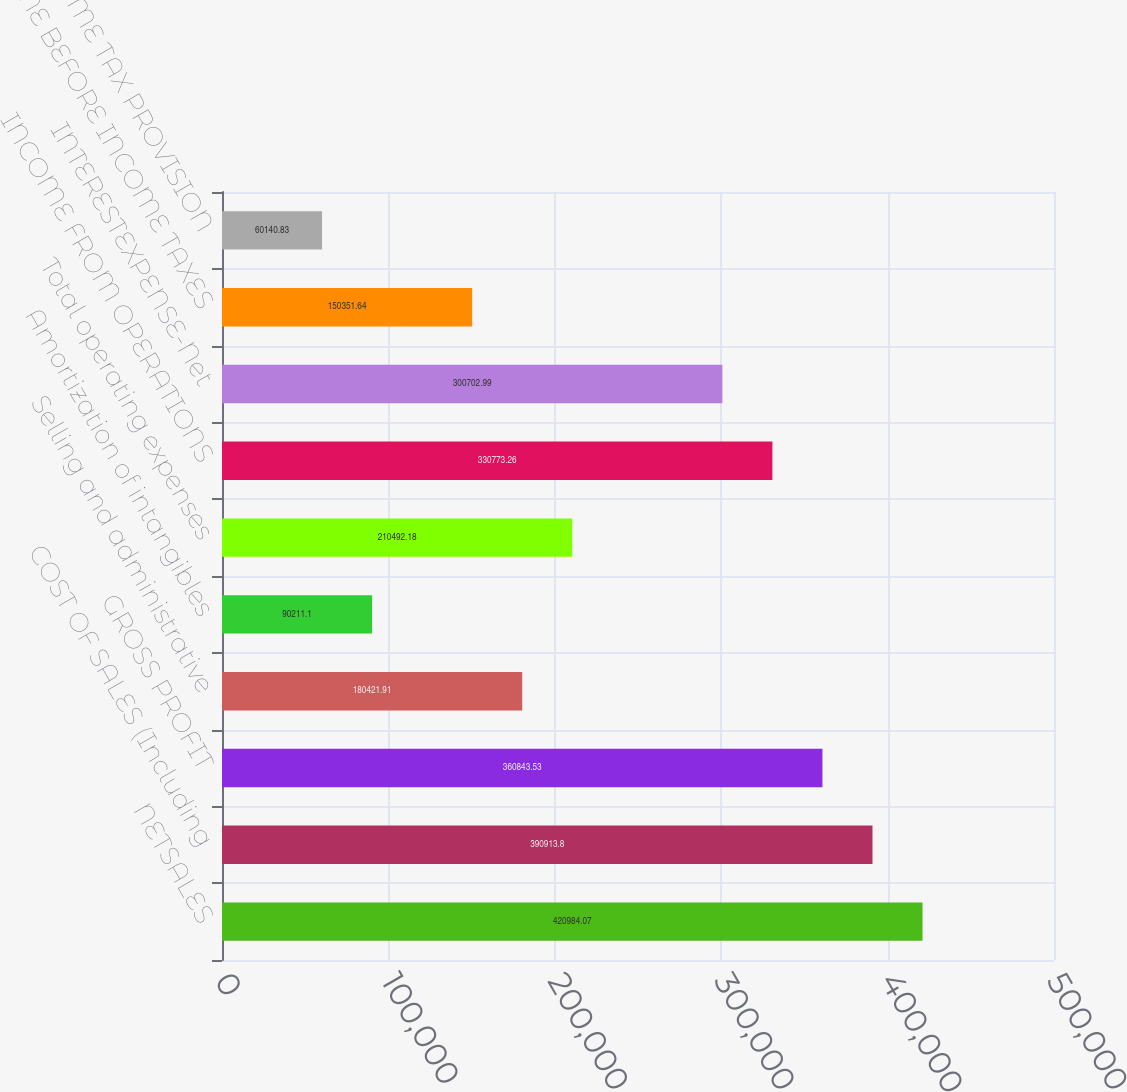<chart> <loc_0><loc_0><loc_500><loc_500><bar_chart><fcel>NETSALES<fcel>COST OF SALES (Including<fcel>GROSS PROFIT<fcel>Selling and administrative<fcel>Amortization of intangibles<fcel>Total operating expenses<fcel>INCOME FROM OPERATIONS<fcel>INTERESTEXPENSE-Net<fcel>INCOME BEFORE INCOME TAXES<fcel>INCOME TAX PROVISION<nl><fcel>420984<fcel>390914<fcel>360844<fcel>180422<fcel>90211.1<fcel>210492<fcel>330773<fcel>300703<fcel>150352<fcel>60140.8<nl></chart> 